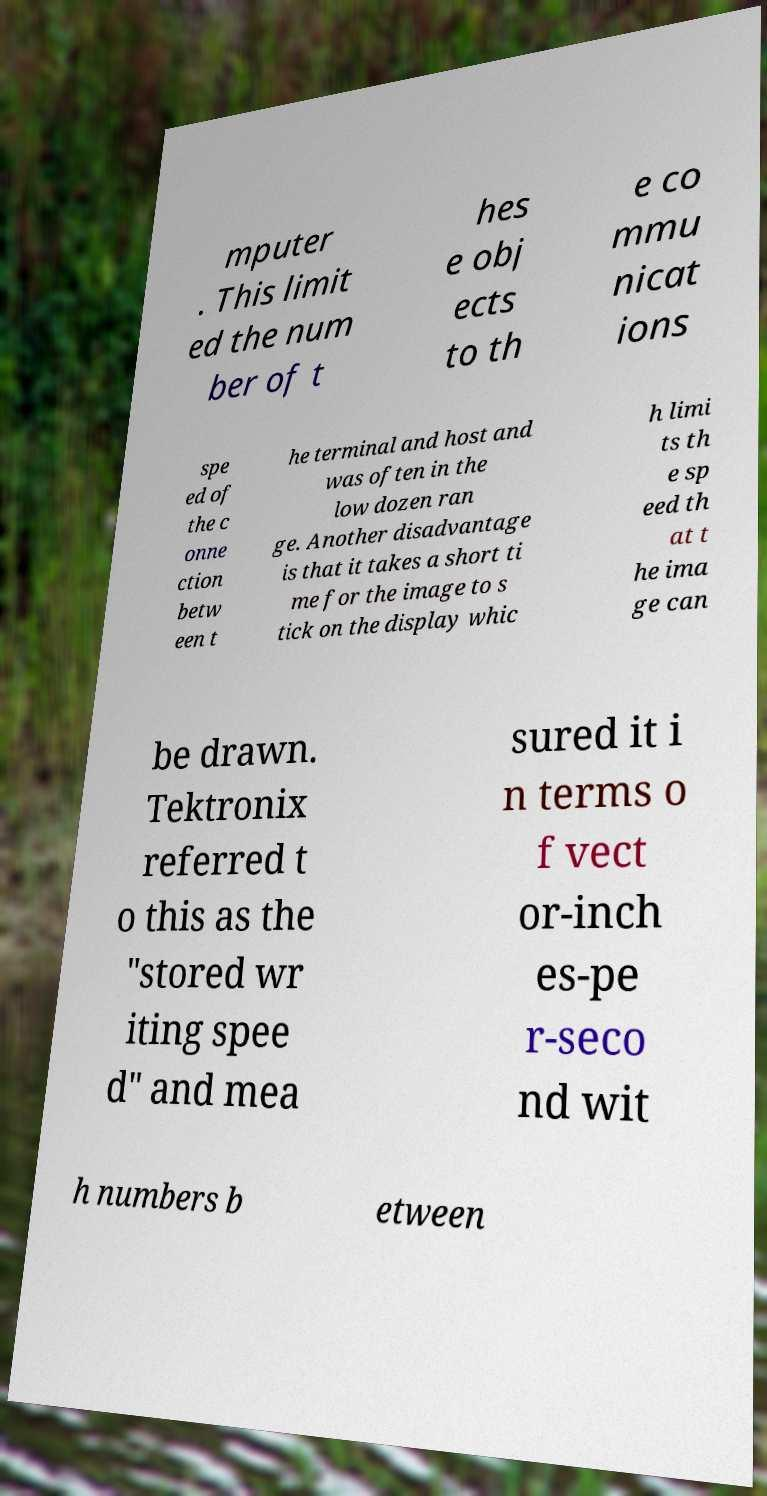I need the written content from this picture converted into text. Can you do that? mputer . This limit ed the num ber of t hes e obj ects to th e co mmu nicat ions spe ed of the c onne ction betw een t he terminal and host and was often in the low dozen ran ge. Another disadvantage is that it takes a short ti me for the image to s tick on the display whic h limi ts th e sp eed th at t he ima ge can be drawn. Tektronix referred t o this as the "stored wr iting spee d" and mea sured it i n terms o f vect or-inch es-pe r-seco nd wit h numbers b etween 